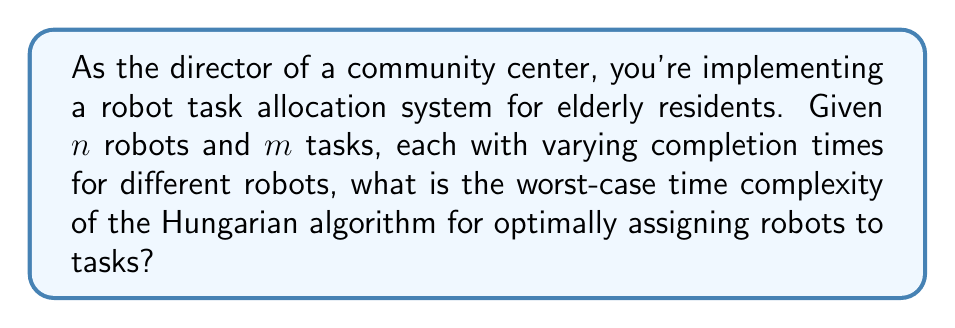Show me your answer to this math problem. To analyze the worst-case time complexity of the Hungarian algorithm for this robot task allocation problem, we need to consider the following steps:

1. Problem Representation:
   The problem can be represented as a bipartite graph with $n$ robots on one side and $m$ tasks on the other. The edge weights represent the time each robot takes to complete each task.

2. Hungarian Algorithm Overview:
   The Hungarian algorithm solves the assignment problem in polynomial time. It works by iteratively improving a matching until an optimal solution is found.

3. Time Complexity Analysis:
   - The algorithm starts with an initial matching and iteratively improves it.
   - In each iteration, it performs a search for an augmenting path.
   - The number of iterations is bounded by $O(n)$ or $O(m)$, whichever is smaller.
   - Each iteration involves a search that can take up to $O(nm)$ time.

4. Worst-Case Scenario:
   The worst-case occurs when the number of robots equals the number of tasks, i.e., $n = m$. In this case:
   - Number of iterations: $O(n)$
   - Time per iteration: $O(n^2)$

5. Final Complexity:
   Combining the number of iterations and time per iteration:
   $$O(n \cdot n^2) = O(n^3)$$

Therefore, the worst-case time complexity of the Hungarian algorithm for this robot task allocation problem is cubic in the number of robots (or tasks, whichever is larger).
Answer: $O(n^3)$, where $n$ is the maximum of the number of robots and tasks. 